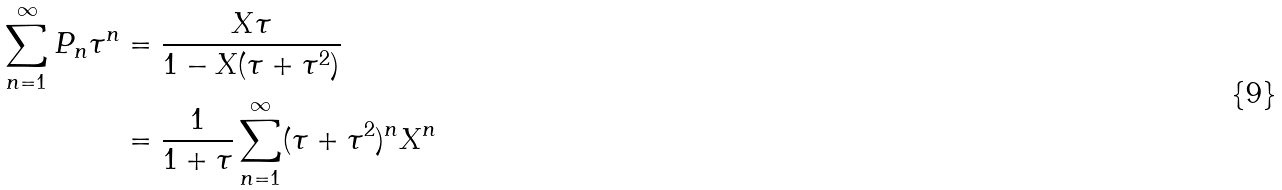<formula> <loc_0><loc_0><loc_500><loc_500>\sum _ { n = 1 } ^ { \infty } P _ { n } \tau ^ { n } & = \frac { X \tau } { 1 - X ( \tau + \tau ^ { 2 } ) } \\ & = \frac { 1 } { 1 + \tau } \sum _ { n = 1 } ^ { \infty } ( \tau + \tau ^ { 2 } ) ^ { n } X ^ { n }</formula> 